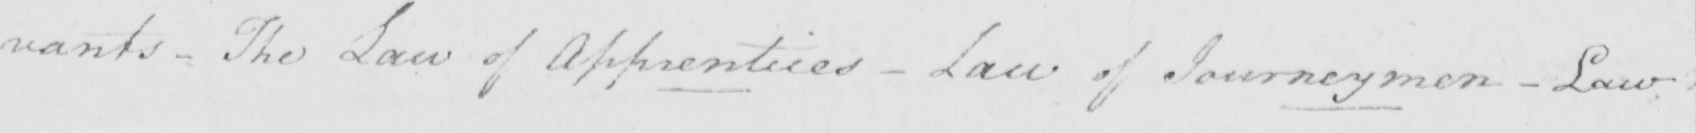What text is written in this handwritten line? vants - The Law of Apprentices  _  Law of Journeymen  _  Law 